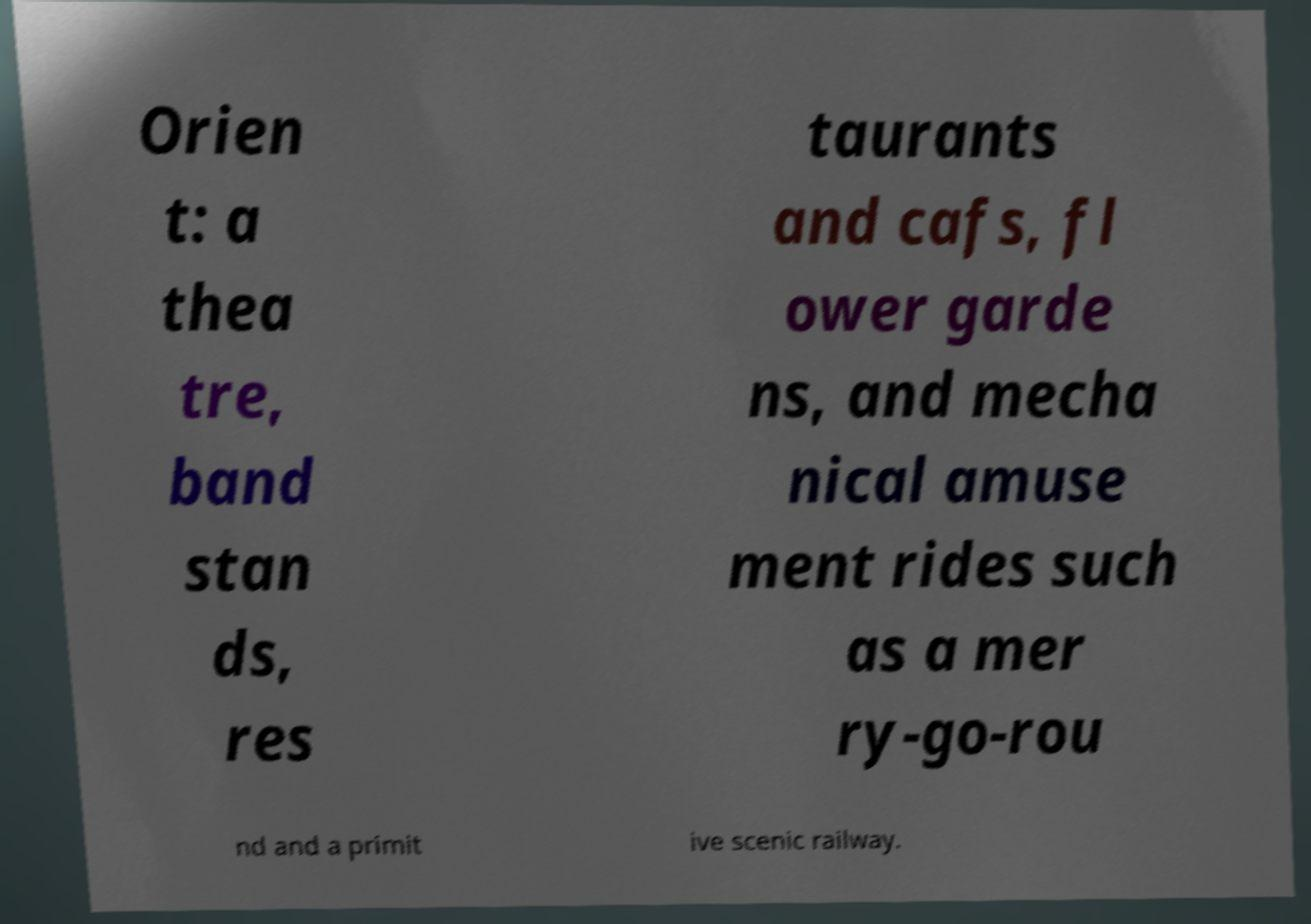Can you read and provide the text displayed in the image?This photo seems to have some interesting text. Can you extract and type it out for me? Orien t: a thea tre, band stan ds, res taurants and cafs, fl ower garde ns, and mecha nical amuse ment rides such as a mer ry-go-rou nd and a primit ive scenic railway. 